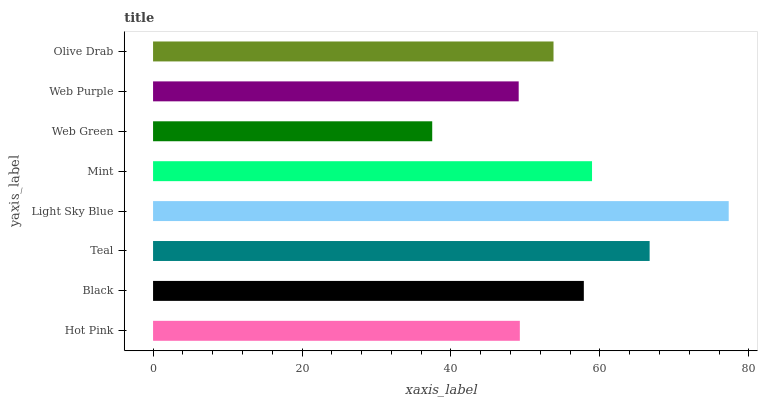Is Web Green the minimum?
Answer yes or no. Yes. Is Light Sky Blue the maximum?
Answer yes or no. Yes. Is Black the minimum?
Answer yes or no. No. Is Black the maximum?
Answer yes or no. No. Is Black greater than Hot Pink?
Answer yes or no. Yes. Is Hot Pink less than Black?
Answer yes or no. Yes. Is Hot Pink greater than Black?
Answer yes or no. No. Is Black less than Hot Pink?
Answer yes or no. No. Is Black the high median?
Answer yes or no. Yes. Is Olive Drab the low median?
Answer yes or no. Yes. Is Web Green the high median?
Answer yes or no. No. Is Mint the low median?
Answer yes or no. No. 